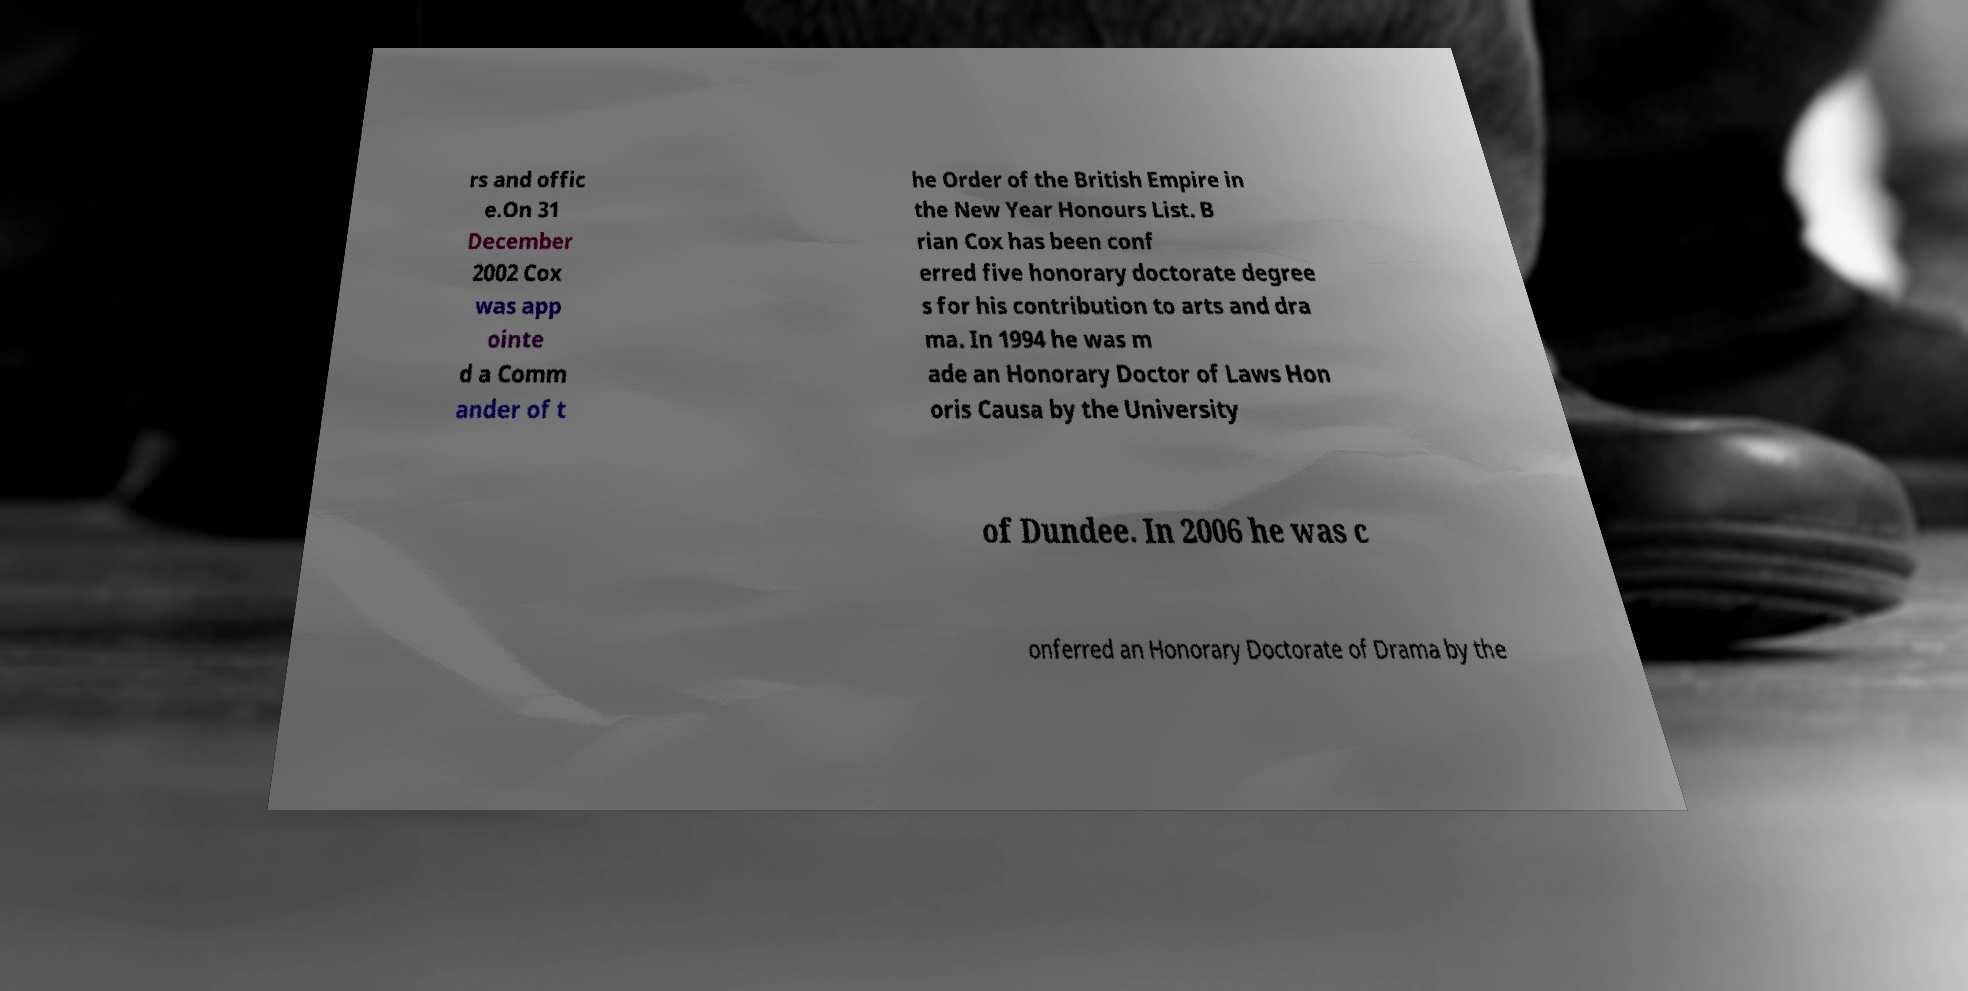Can you read and provide the text displayed in the image?This photo seems to have some interesting text. Can you extract and type it out for me? rs and offic e.On 31 December 2002 Cox was app ointe d a Comm ander of t he Order of the British Empire in the New Year Honours List. B rian Cox has been conf erred five honorary doctorate degree s for his contribution to arts and dra ma. In 1994 he was m ade an Honorary Doctor of Laws Hon oris Causa by the University of Dundee. In 2006 he was c onferred an Honorary Doctorate of Drama by the 